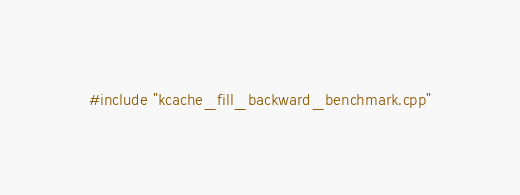Convert code to text. <code><loc_0><loc_0><loc_500><loc_500><_Cuda_>#include "kcache_fill_backward_benchmark.cpp"
</code> 